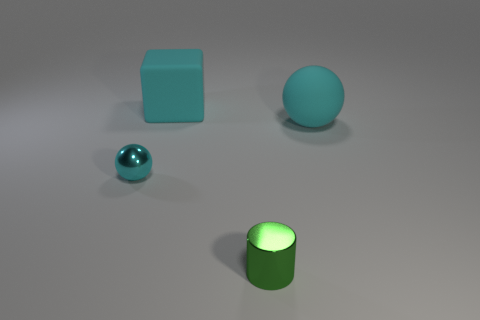Are there fewer big matte objects that are to the left of the cyan metal sphere than small cylinders in front of the large cyan sphere? From what we can observe, there appears to be only one large matte object to the left of the cyan metal sphere. Comparing this to the small green cylinder in front of the large cyan sphere, we can confirm that there is indeed a smaller number of big matte objects in the specified area than small cylinders. 